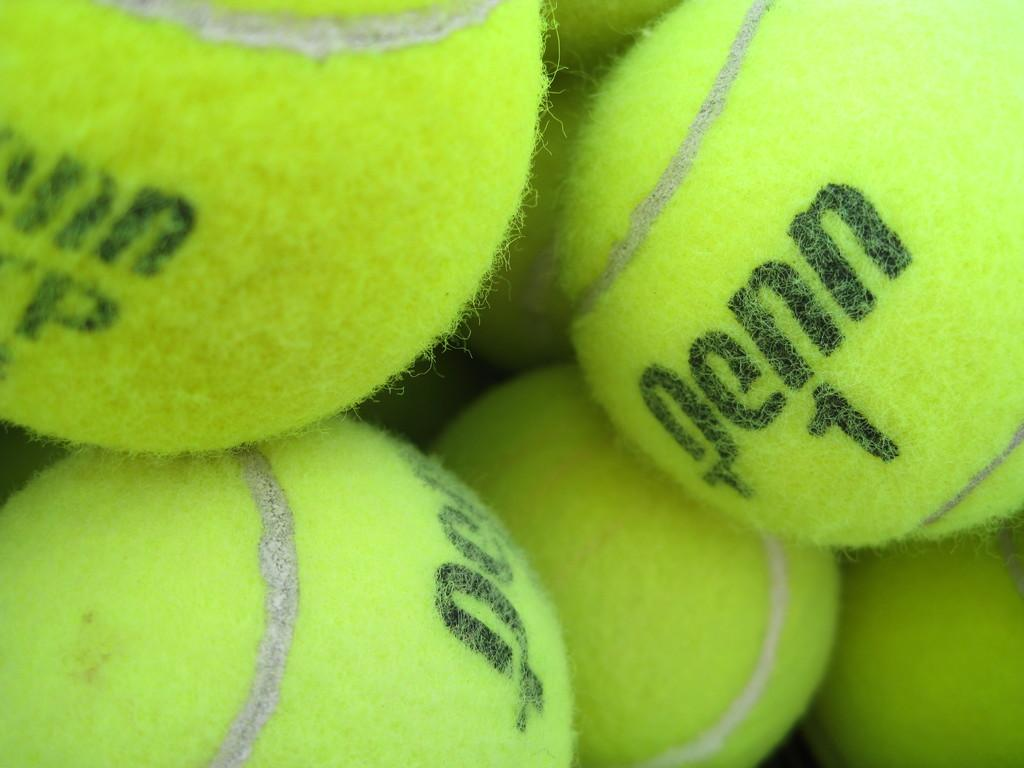What objects are present in the image related to sports? There are tennis balls in the image. What is written or printed on the tennis balls? There is text on the tennis balls. What color are the tennis balls in the image? The tennis balls are green in color. How many light bulbs are hanging above the tennis balls in the image? There are no light bulbs present in the image; it only features tennis balls with text on them. 